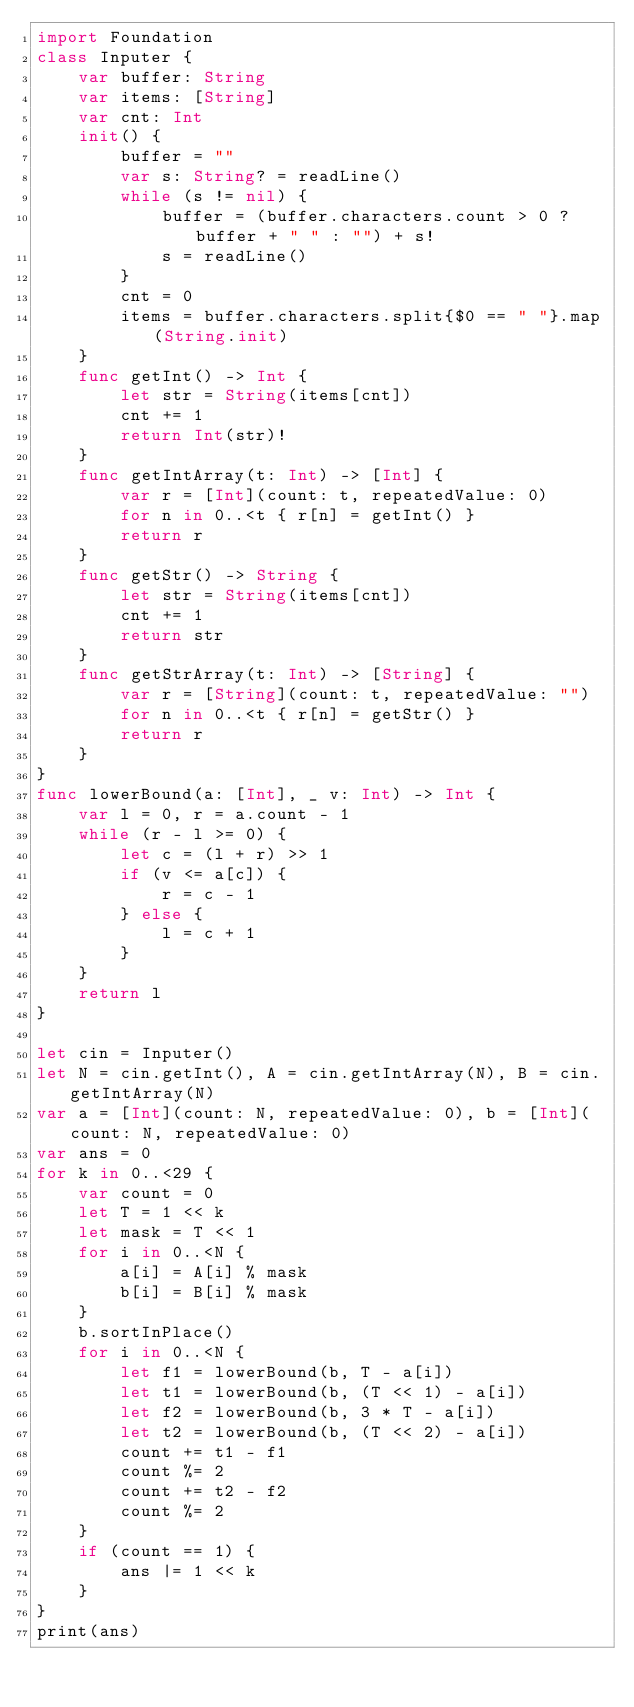<code> <loc_0><loc_0><loc_500><loc_500><_Swift_>import Foundation
class Inputer {
    var buffer: String
    var items: [String]
    var cnt: Int
    init() {
        buffer = ""
        var s: String? = readLine()
        while (s != nil) {
            buffer = (buffer.characters.count > 0 ? buffer + " " : "") + s!
            s = readLine()
        }
        cnt = 0
        items = buffer.characters.split{$0 == " "}.map(String.init)
    }
    func getInt() -> Int {
        let str = String(items[cnt])
        cnt += 1
        return Int(str)!
    }
    func getIntArray(t: Int) -> [Int] {
        var r = [Int](count: t, repeatedValue: 0)
        for n in 0..<t { r[n] = getInt() }
        return r
    }
    func getStr() -> String {
        let str = String(items[cnt])
        cnt += 1
        return str
    }
    func getStrArray(t: Int) -> [String] {
        var r = [String](count: t, repeatedValue: "")
        for n in 0..<t { r[n] = getStr() }
        return r
    }
}
func lowerBound(a: [Int], _ v: Int) -> Int {
    var l = 0, r = a.count - 1
    while (r - l >= 0) {
        let c = (l + r) >> 1
        if (v <= a[c]) {
            r = c - 1
        } else {
            l = c + 1
        }
    }
    return l
}

let cin = Inputer()
let N = cin.getInt(), A = cin.getIntArray(N), B = cin.getIntArray(N)
var a = [Int](count: N, repeatedValue: 0), b = [Int](count: N, repeatedValue: 0)
var ans = 0
for k in 0..<29 {
    var count = 0
    let T = 1 << k
    let mask = T << 1
    for i in 0..<N {
        a[i] = A[i] % mask
        b[i] = B[i] % mask
    }
    b.sortInPlace()
    for i in 0..<N {
        let f1 = lowerBound(b, T - a[i])
        let t1 = lowerBound(b, (T << 1) - a[i])
        let f2 = lowerBound(b, 3 * T - a[i])
        let t2 = lowerBound(b, (T << 2) - a[i])
        count += t1 - f1
        count %= 2
        count += t2 - f2
        count %= 2
    }
    if (count == 1) {
        ans |= 1 << k
    }
}
print(ans)
</code> 